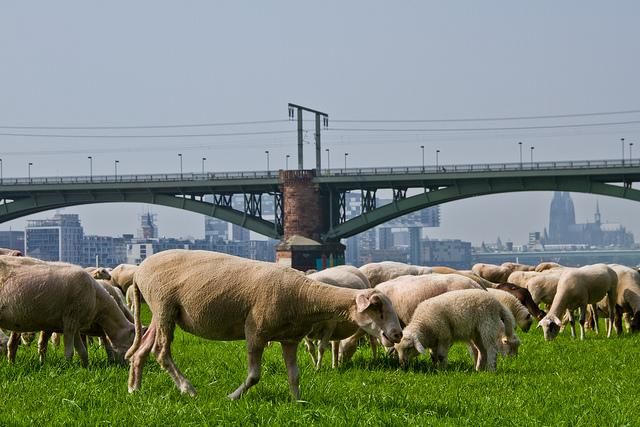What color is the cast iron component in the bridge above the grassy field? green 